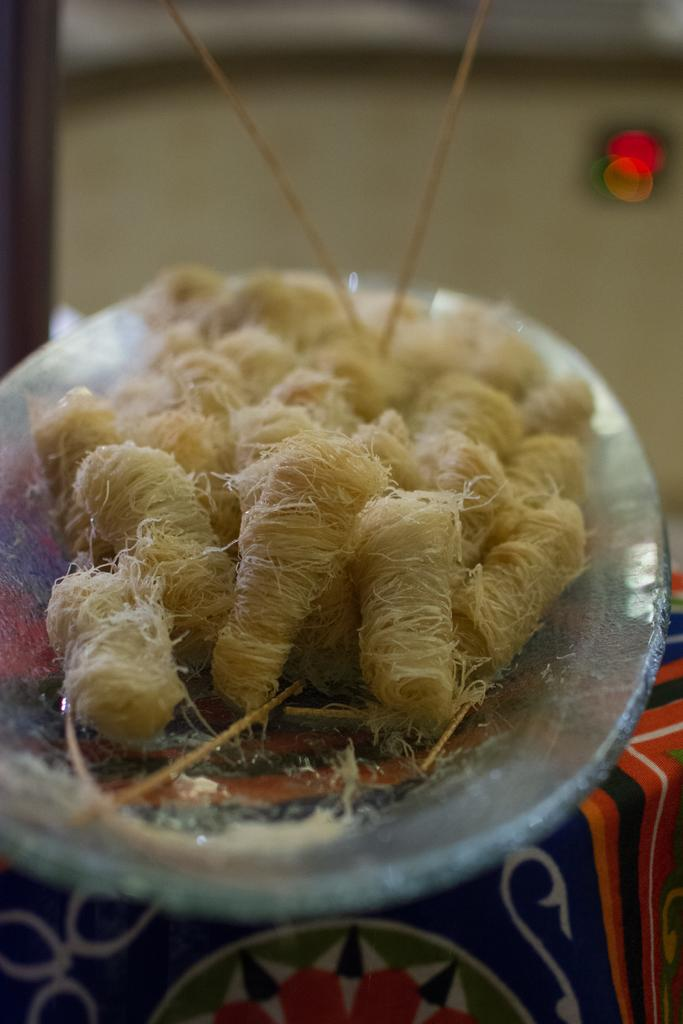What is on the glass plate in the image? The glass plate has thread balls on it. Where is the glass plate located? The glass plate is on a table. What else is on the table in the image? There is a cloth on the table. What can be seen in the top right corner of the image? There is a red color light on the right side top of the image. What type of card is being used to cast a spell in the image? There is no card or spell casting present in the image; it features a glass plate with thread balls on a table, a cloth, and a red color light. 